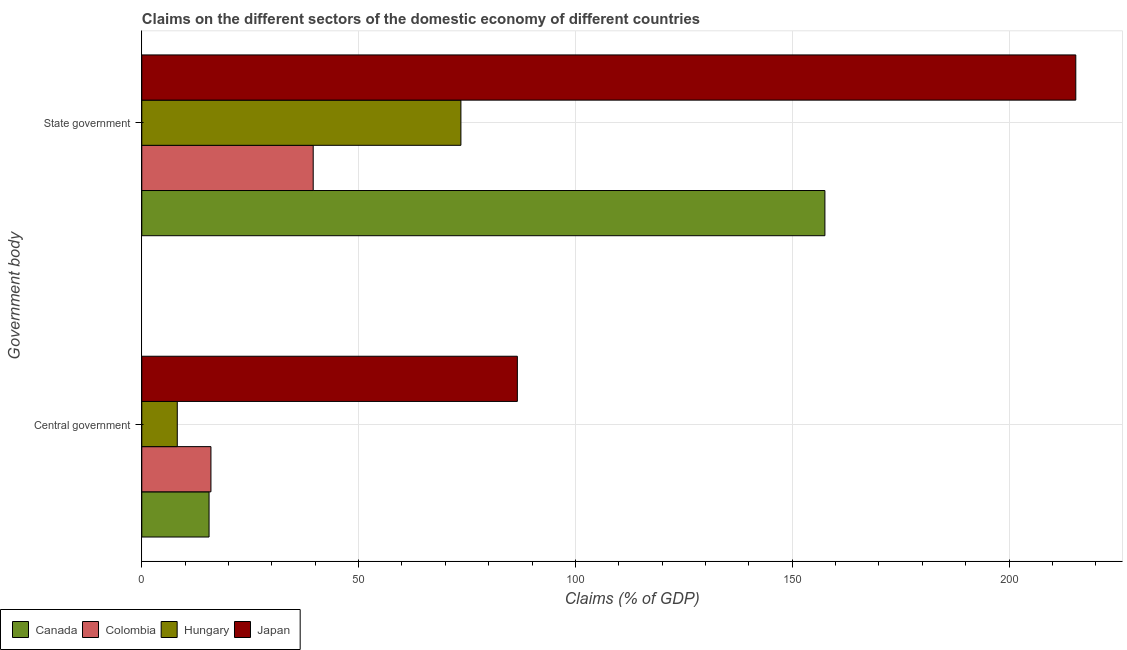Are the number of bars per tick equal to the number of legend labels?
Provide a succinct answer. Yes. How many bars are there on the 2nd tick from the bottom?
Your answer should be compact. 4. What is the label of the 1st group of bars from the top?
Keep it short and to the point. State government. What is the claims on central government in Colombia?
Make the answer very short. 15.95. Across all countries, what is the maximum claims on state government?
Give a very brief answer. 215.41. Across all countries, what is the minimum claims on state government?
Your answer should be very brief. 39.53. In which country was the claims on state government minimum?
Offer a terse response. Colombia. What is the total claims on central government in the graph?
Keep it short and to the point. 126.25. What is the difference between the claims on central government in Hungary and that in Canada?
Provide a short and direct response. -7.33. What is the difference between the claims on central government in Hungary and the claims on state government in Canada?
Give a very brief answer. -149.36. What is the average claims on state government per country?
Your response must be concise. 121.52. What is the difference between the claims on state government and claims on central government in Japan?
Your answer should be compact. 128.79. What is the ratio of the claims on central government in Japan to that in Canada?
Offer a terse response. 5.58. What does the 1st bar from the bottom in Central government represents?
Provide a short and direct response. Canada. How many bars are there?
Your answer should be compact. 8. Are all the bars in the graph horizontal?
Provide a succinct answer. Yes. How many countries are there in the graph?
Provide a succinct answer. 4. Are the values on the major ticks of X-axis written in scientific E-notation?
Your answer should be very brief. No. Does the graph contain grids?
Your response must be concise. Yes. How many legend labels are there?
Ensure brevity in your answer.  4. What is the title of the graph?
Provide a succinct answer. Claims on the different sectors of the domestic economy of different countries. Does "World" appear as one of the legend labels in the graph?
Your answer should be very brief. No. What is the label or title of the X-axis?
Ensure brevity in your answer.  Claims (% of GDP). What is the label or title of the Y-axis?
Your answer should be very brief. Government body. What is the Claims (% of GDP) in Canada in Central government?
Give a very brief answer. 15.51. What is the Claims (% of GDP) of Colombia in Central government?
Offer a terse response. 15.95. What is the Claims (% of GDP) in Hungary in Central government?
Ensure brevity in your answer.  8.18. What is the Claims (% of GDP) in Japan in Central government?
Your answer should be very brief. 86.61. What is the Claims (% of GDP) of Canada in State government?
Offer a terse response. 157.54. What is the Claims (% of GDP) of Colombia in State government?
Provide a short and direct response. 39.53. What is the Claims (% of GDP) of Hungary in State government?
Your response must be concise. 73.59. What is the Claims (% of GDP) of Japan in State government?
Provide a short and direct response. 215.41. Across all Government body, what is the maximum Claims (% of GDP) in Canada?
Give a very brief answer. 157.54. Across all Government body, what is the maximum Claims (% of GDP) in Colombia?
Ensure brevity in your answer.  39.53. Across all Government body, what is the maximum Claims (% of GDP) of Hungary?
Offer a very short reply. 73.59. Across all Government body, what is the maximum Claims (% of GDP) in Japan?
Provide a short and direct response. 215.41. Across all Government body, what is the minimum Claims (% of GDP) in Canada?
Make the answer very short. 15.51. Across all Government body, what is the minimum Claims (% of GDP) in Colombia?
Your response must be concise. 15.95. Across all Government body, what is the minimum Claims (% of GDP) in Hungary?
Your response must be concise. 8.18. Across all Government body, what is the minimum Claims (% of GDP) in Japan?
Provide a succinct answer. 86.61. What is the total Claims (% of GDP) of Canada in the graph?
Your answer should be very brief. 173.05. What is the total Claims (% of GDP) in Colombia in the graph?
Give a very brief answer. 55.48. What is the total Claims (% of GDP) in Hungary in the graph?
Your answer should be very brief. 81.78. What is the total Claims (% of GDP) in Japan in the graph?
Keep it short and to the point. 302.02. What is the difference between the Claims (% of GDP) of Canada in Central government and that in State government?
Ensure brevity in your answer.  -142.03. What is the difference between the Claims (% of GDP) in Colombia in Central government and that in State government?
Your answer should be compact. -23.59. What is the difference between the Claims (% of GDP) in Hungary in Central government and that in State government?
Give a very brief answer. -65.41. What is the difference between the Claims (% of GDP) in Japan in Central government and that in State government?
Offer a terse response. -128.79. What is the difference between the Claims (% of GDP) in Canada in Central government and the Claims (% of GDP) in Colombia in State government?
Your answer should be very brief. -24.02. What is the difference between the Claims (% of GDP) of Canada in Central government and the Claims (% of GDP) of Hungary in State government?
Offer a terse response. -58.08. What is the difference between the Claims (% of GDP) of Canada in Central government and the Claims (% of GDP) of Japan in State government?
Your response must be concise. -199.89. What is the difference between the Claims (% of GDP) of Colombia in Central government and the Claims (% of GDP) of Hungary in State government?
Your answer should be very brief. -57.65. What is the difference between the Claims (% of GDP) of Colombia in Central government and the Claims (% of GDP) of Japan in State government?
Your answer should be very brief. -199.46. What is the difference between the Claims (% of GDP) in Hungary in Central government and the Claims (% of GDP) in Japan in State government?
Ensure brevity in your answer.  -207.22. What is the average Claims (% of GDP) in Canada per Government body?
Give a very brief answer. 86.53. What is the average Claims (% of GDP) of Colombia per Government body?
Make the answer very short. 27.74. What is the average Claims (% of GDP) of Hungary per Government body?
Offer a very short reply. 40.89. What is the average Claims (% of GDP) of Japan per Government body?
Give a very brief answer. 151.01. What is the difference between the Claims (% of GDP) in Canada and Claims (% of GDP) in Colombia in Central government?
Your response must be concise. -0.43. What is the difference between the Claims (% of GDP) in Canada and Claims (% of GDP) in Hungary in Central government?
Offer a terse response. 7.33. What is the difference between the Claims (% of GDP) in Canada and Claims (% of GDP) in Japan in Central government?
Make the answer very short. -71.1. What is the difference between the Claims (% of GDP) in Colombia and Claims (% of GDP) in Hungary in Central government?
Provide a succinct answer. 7.76. What is the difference between the Claims (% of GDP) of Colombia and Claims (% of GDP) of Japan in Central government?
Offer a very short reply. -70.67. What is the difference between the Claims (% of GDP) in Hungary and Claims (% of GDP) in Japan in Central government?
Give a very brief answer. -78.43. What is the difference between the Claims (% of GDP) in Canada and Claims (% of GDP) in Colombia in State government?
Provide a short and direct response. 118.01. What is the difference between the Claims (% of GDP) of Canada and Claims (% of GDP) of Hungary in State government?
Your answer should be very brief. 83.95. What is the difference between the Claims (% of GDP) of Canada and Claims (% of GDP) of Japan in State government?
Your answer should be compact. -57.86. What is the difference between the Claims (% of GDP) in Colombia and Claims (% of GDP) in Hungary in State government?
Offer a very short reply. -34.06. What is the difference between the Claims (% of GDP) in Colombia and Claims (% of GDP) in Japan in State government?
Keep it short and to the point. -175.88. What is the difference between the Claims (% of GDP) in Hungary and Claims (% of GDP) in Japan in State government?
Offer a very short reply. -141.81. What is the ratio of the Claims (% of GDP) in Canada in Central government to that in State government?
Provide a short and direct response. 0.1. What is the ratio of the Claims (% of GDP) of Colombia in Central government to that in State government?
Make the answer very short. 0.4. What is the ratio of the Claims (% of GDP) in Hungary in Central government to that in State government?
Your answer should be very brief. 0.11. What is the ratio of the Claims (% of GDP) in Japan in Central government to that in State government?
Offer a very short reply. 0.4. What is the difference between the highest and the second highest Claims (% of GDP) of Canada?
Provide a short and direct response. 142.03. What is the difference between the highest and the second highest Claims (% of GDP) in Colombia?
Your response must be concise. 23.59. What is the difference between the highest and the second highest Claims (% of GDP) of Hungary?
Offer a very short reply. 65.41. What is the difference between the highest and the second highest Claims (% of GDP) of Japan?
Your answer should be very brief. 128.79. What is the difference between the highest and the lowest Claims (% of GDP) of Canada?
Your answer should be compact. 142.03. What is the difference between the highest and the lowest Claims (% of GDP) of Colombia?
Give a very brief answer. 23.59. What is the difference between the highest and the lowest Claims (% of GDP) of Hungary?
Offer a terse response. 65.41. What is the difference between the highest and the lowest Claims (% of GDP) of Japan?
Your answer should be very brief. 128.79. 